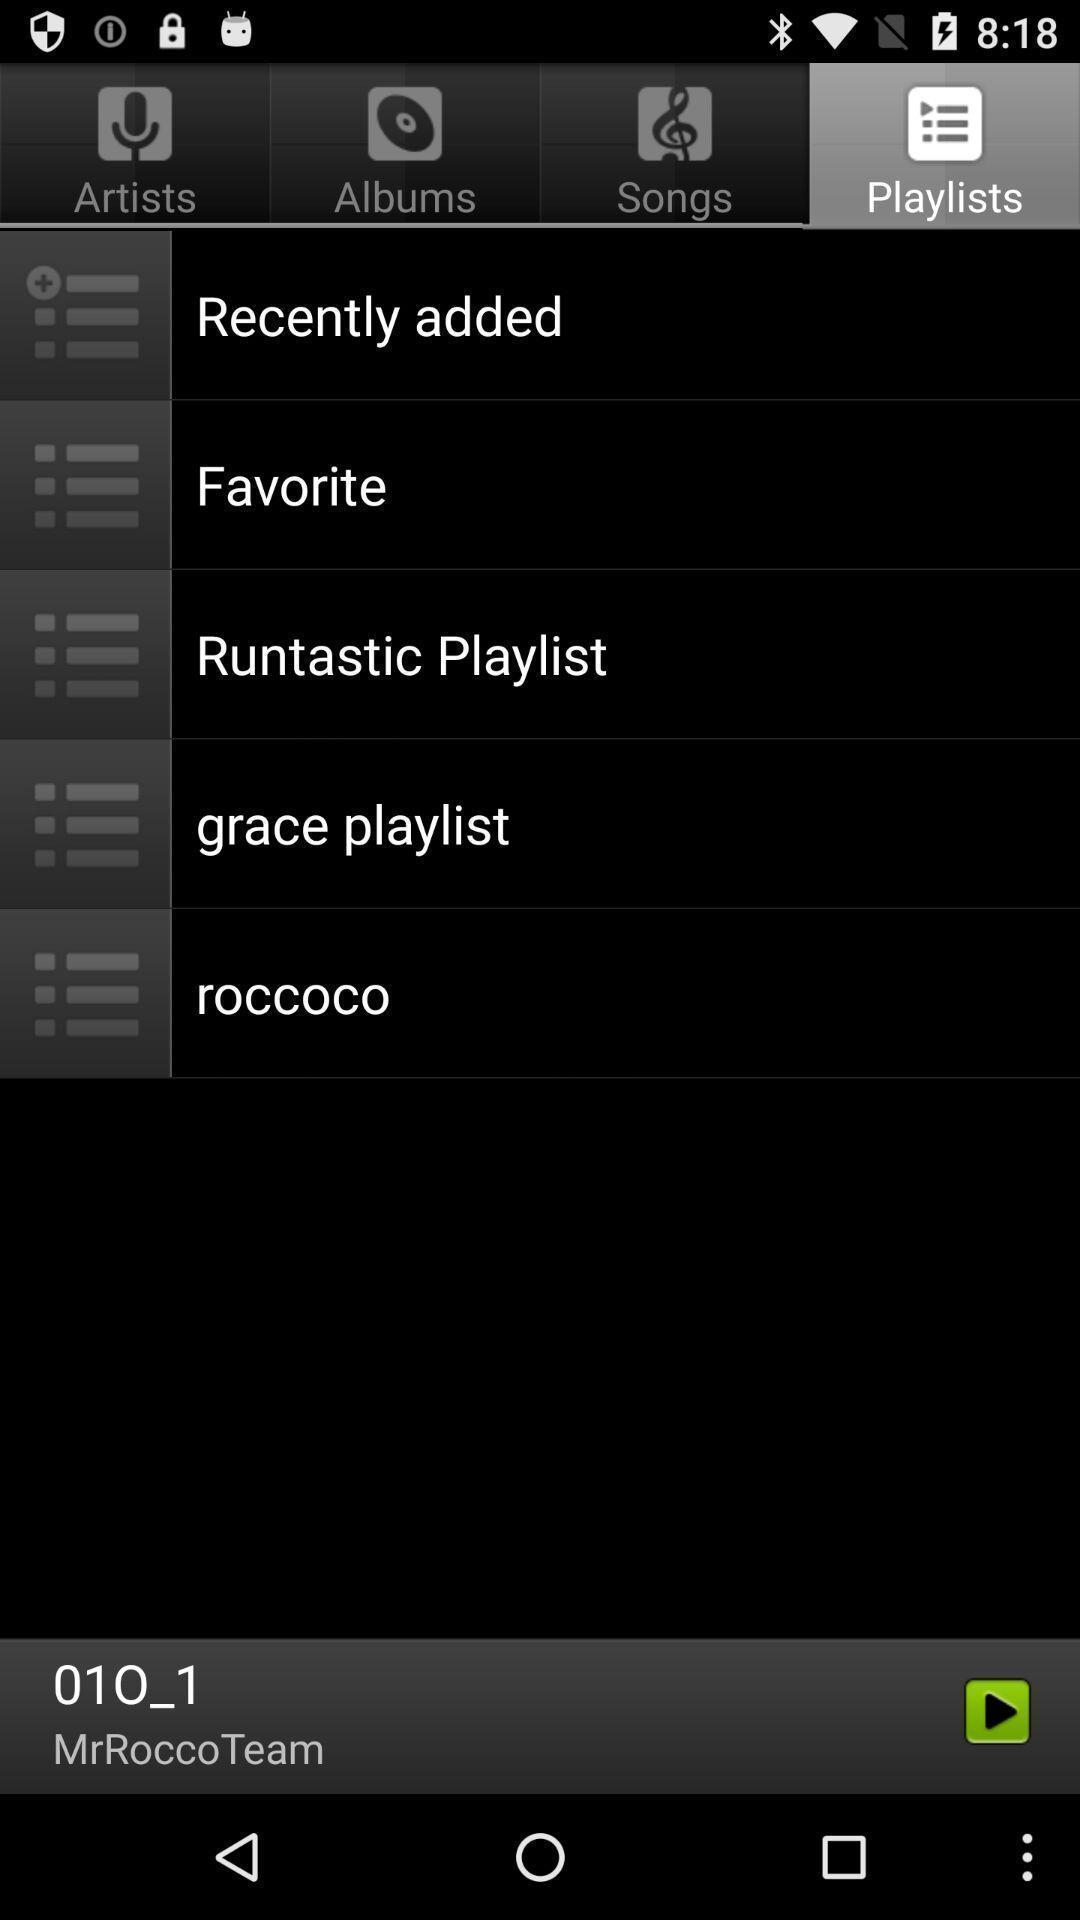Provide a textual representation of this image. Screen displaying a list of playlist names. 